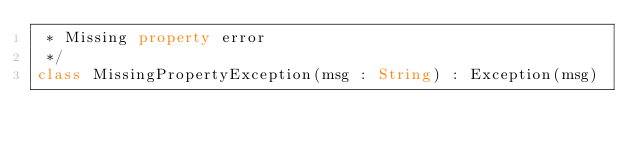<code> <loc_0><loc_0><loc_500><loc_500><_Kotlin_> * Missing property error
 */
class MissingPropertyException(msg : String) : Exception(msg)</code> 